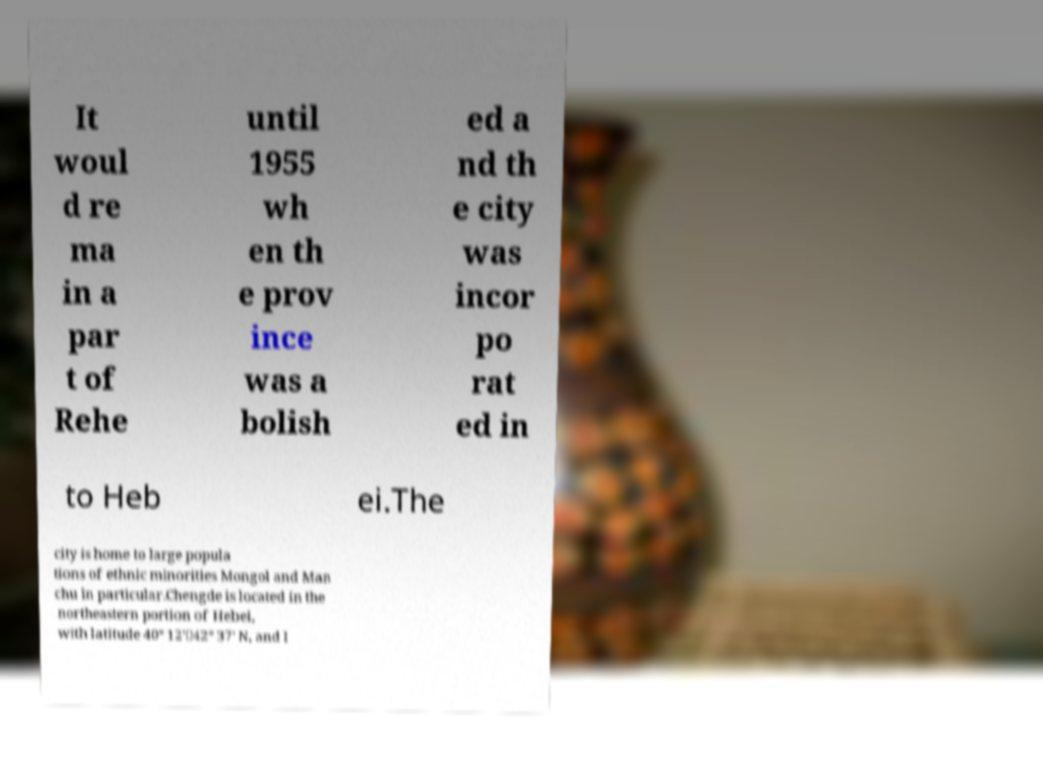Can you read and provide the text displayed in the image?This photo seems to have some interesting text. Can you extract and type it out for me? It woul d re ma in a par t of Rehe until 1955 wh en th e prov ince was a bolish ed a nd th e city was incor po rat ed in to Heb ei.The city is home to large popula tions of ethnic minorities Mongol and Man chu in particular.Chengde is located in the northeastern portion of Hebei, with latitude 40° 12'－42° 37' N, and l 